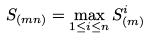<formula> <loc_0><loc_0><loc_500><loc_500>S _ { ( m n ) } = \max _ { 1 \leq i \leq n } S ^ { i } _ { ( m ) }</formula> 